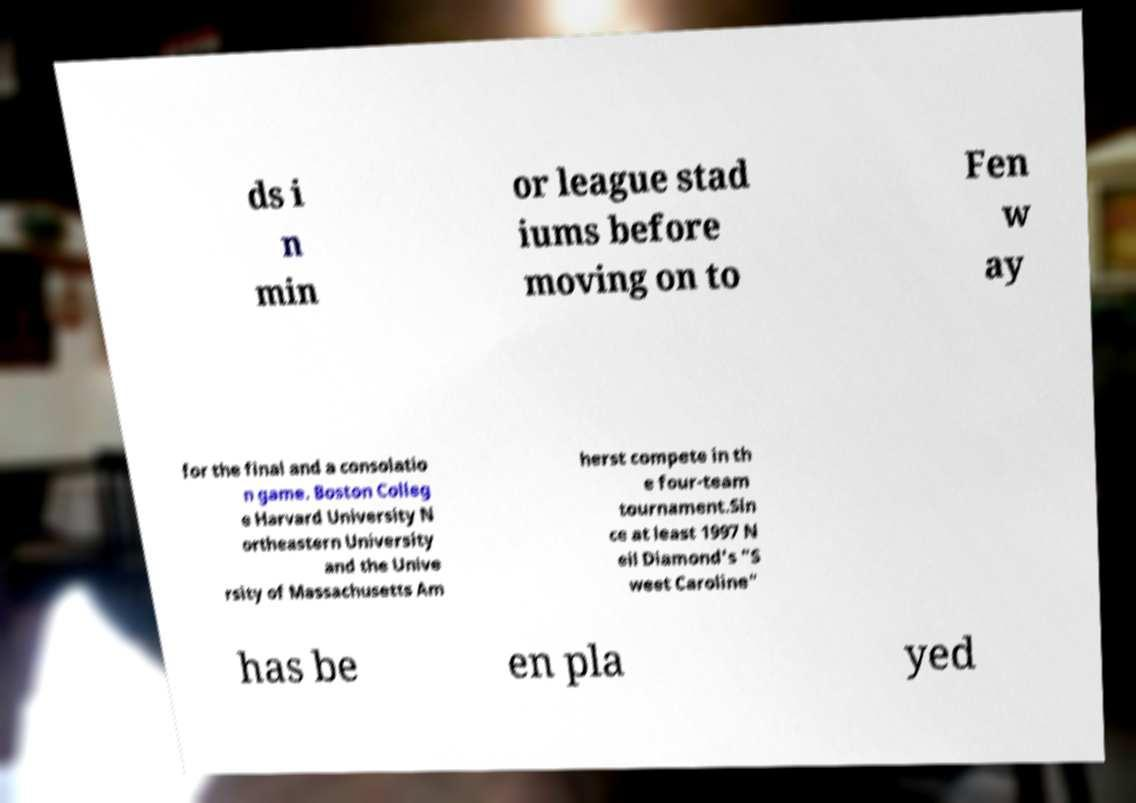Can you read and provide the text displayed in the image?This photo seems to have some interesting text. Can you extract and type it out for me? ds i n min or league stad iums before moving on to Fen w ay for the final and a consolatio n game. Boston Colleg e Harvard University N ortheastern University and the Unive rsity of Massachusetts Am herst compete in th e four-team tournament.Sin ce at least 1997 N eil Diamond's "S weet Caroline" has be en pla yed 